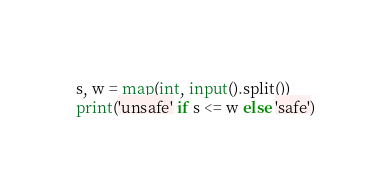Convert code to text. <code><loc_0><loc_0><loc_500><loc_500><_Python_>s, w = map(int, input().split())
print('unsafe' if s <= w else 'safe')</code> 